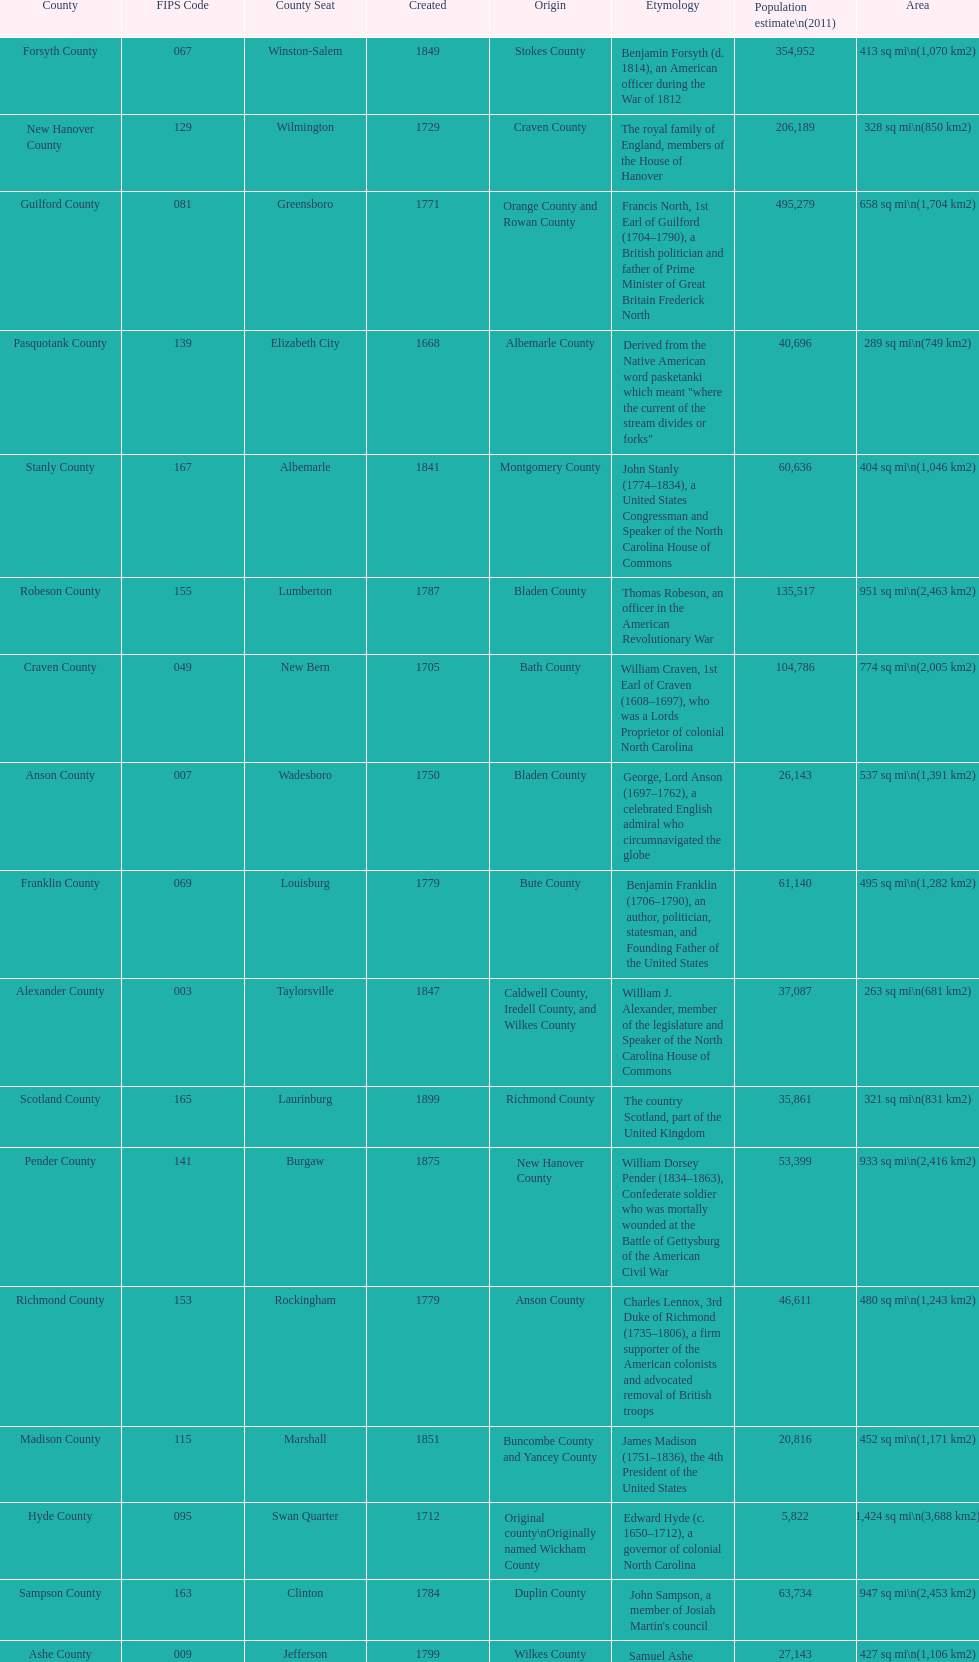What is the number of counties created in the 1800s? 37. 